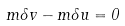Convert formula to latex. <formula><loc_0><loc_0><loc_500><loc_500>m \delta v - m \delta u = 0</formula> 